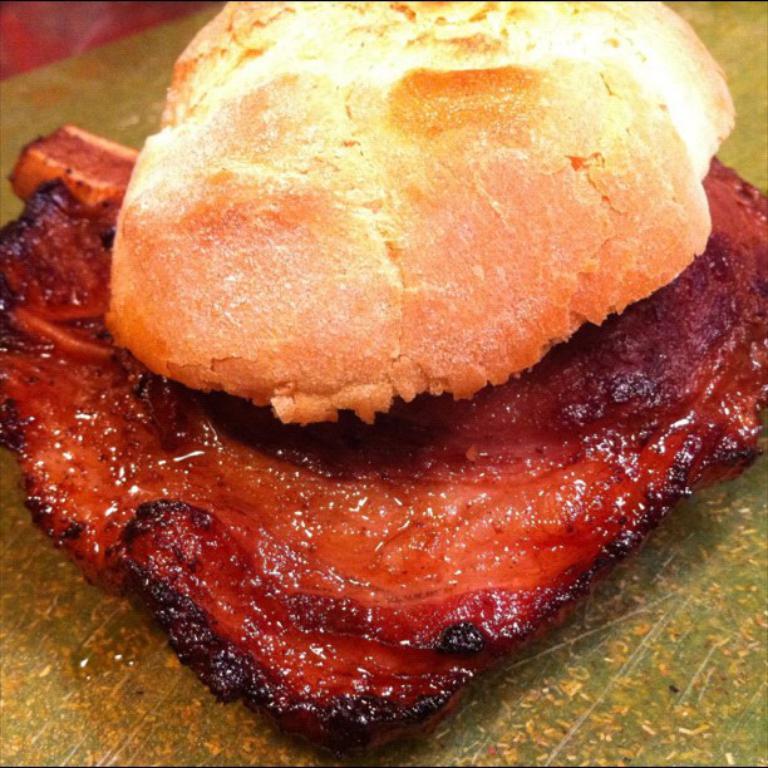Could you give a brief overview of what you see in this image? There is a puff on the fried meat which is on the plastic cover. And this plastic cover on the table. 